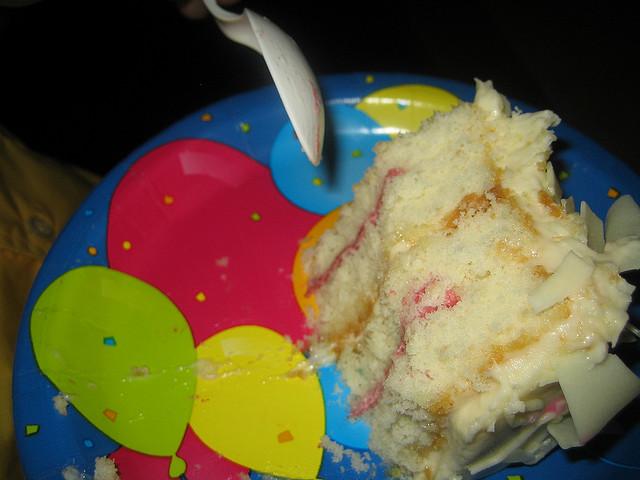What is on the knife?
Write a very short answer. Cake. Are the balloons real?
Short answer required. No. What are they likely celebrating?
Keep it brief. Birthday. 